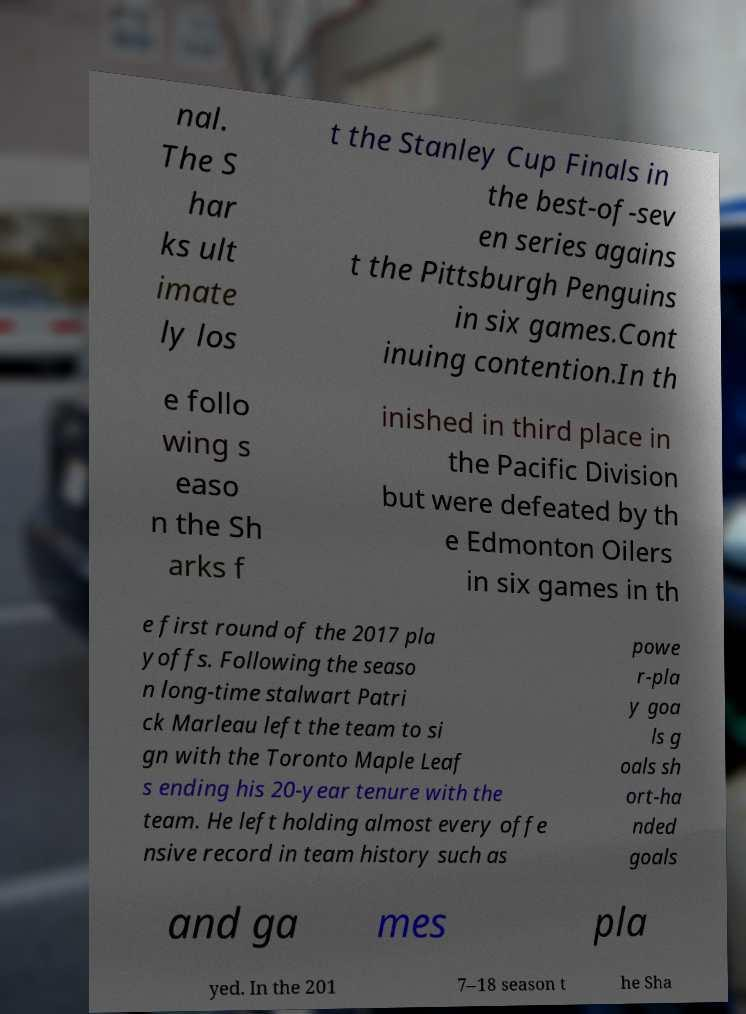Could you extract and type out the text from this image? nal. The S har ks ult imate ly los t the Stanley Cup Finals in the best-of-sev en series agains t the Pittsburgh Penguins in six games.Cont inuing contention.In th e follo wing s easo n the Sh arks f inished in third place in the Pacific Division but were defeated by th e Edmonton Oilers in six games in th e first round of the 2017 pla yoffs. Following the seaso n long-time stalwart Patri ck Marleau left the team to si gn with the Toronto Maple Leaf s ending his 20-year tenure with the team. He left holding almost every offe nsive record in team history such as powe r-pla y goa ls g oals sh ort-ha nded goals and ga mes pla yed. In the 201 7–18 season t he Sha 